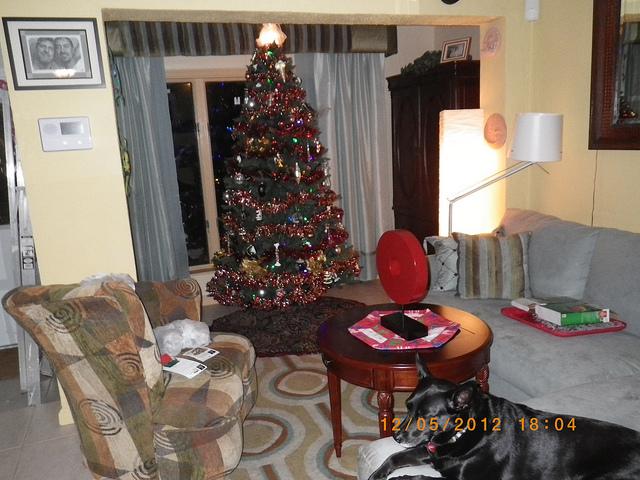What is the date on the picture?
Concise answer only. 12/05/2012. How many pillows on the couch?
Concise answer only. 2. Is this an artificial Christmas tree?
Short answer required. Yes. Is there a pattern on the rug?
Quick response, please. Yes. 